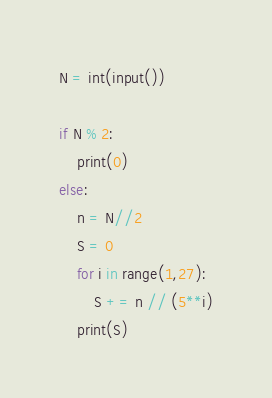Convert code to text. <code><loc_0><loc_0><loc_500><loc_500><_Python_>N = int(input())

if N % 2:
    print(0)
else:
    n = N//2
    S = 0
    for i in range(1,27):
        S += n // (5**i)
    print(S)</code> 